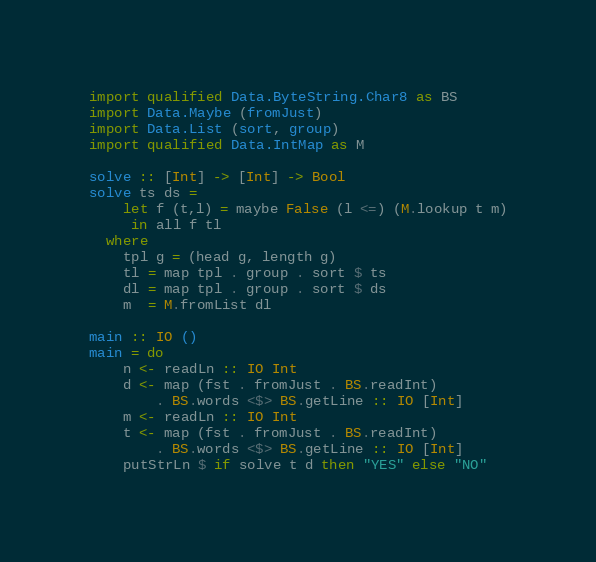<code> <loc_0><loc_0><loc_500><loc_500><_Haskell_>import qualified Data.ByteString.Char8 as BS
import Data.Maybe (fromJust)
import Data.List (sort, group)
import qualified Data.IntMap as M

solve :: [Int] -> [Int] -> Bool
solve ts ds =
    let f (t,l) = maybe False (l <=) (M.lookup t m)
     in all f tl
  where
    tpl g = (head g, length g)
    tl = map tpl . group . sort $ ts
    dl = map tpl . group . sort $ ds
    m  = M.fromList dl

main :: IO ()
main = do
    n <- readLn :: IO Int
    d <- map (fst . fromJust . BS.readInt)
        . BS.words <$> BS.getLine :: IO [Int]
    m <- readLn :: IO Int
    t <- map (fst . fromJust . BS.readInt)
        . BS.words <$> BS.getLine :: IO [Int]
    putStrLn $ if solve t d then "YES" else "NO"</code> 